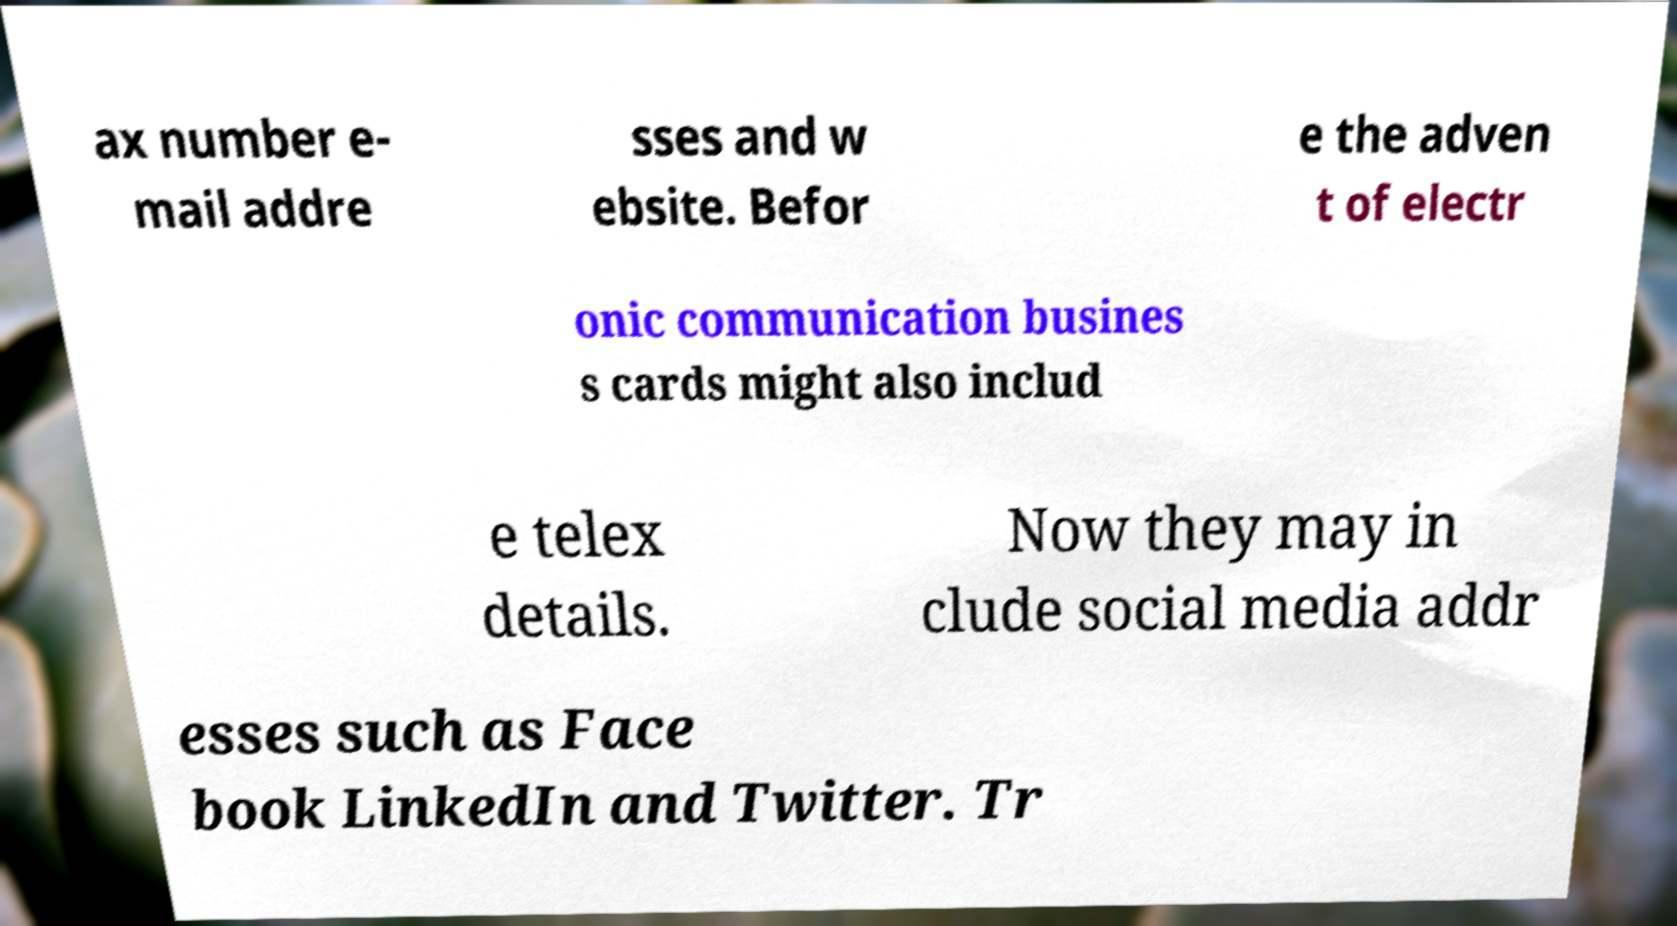Can you read and provide the text displayed in the image?This photo seems to have some interesting text. Can you extract and type it out for me? ax number e- mail addre sses and w ebsite. Befor e the adven t of electr onic communication busines s cards might also includ e telex details. Now they may in clude social media addr esses such as Face book LinkedIn and Twitter. Tr 